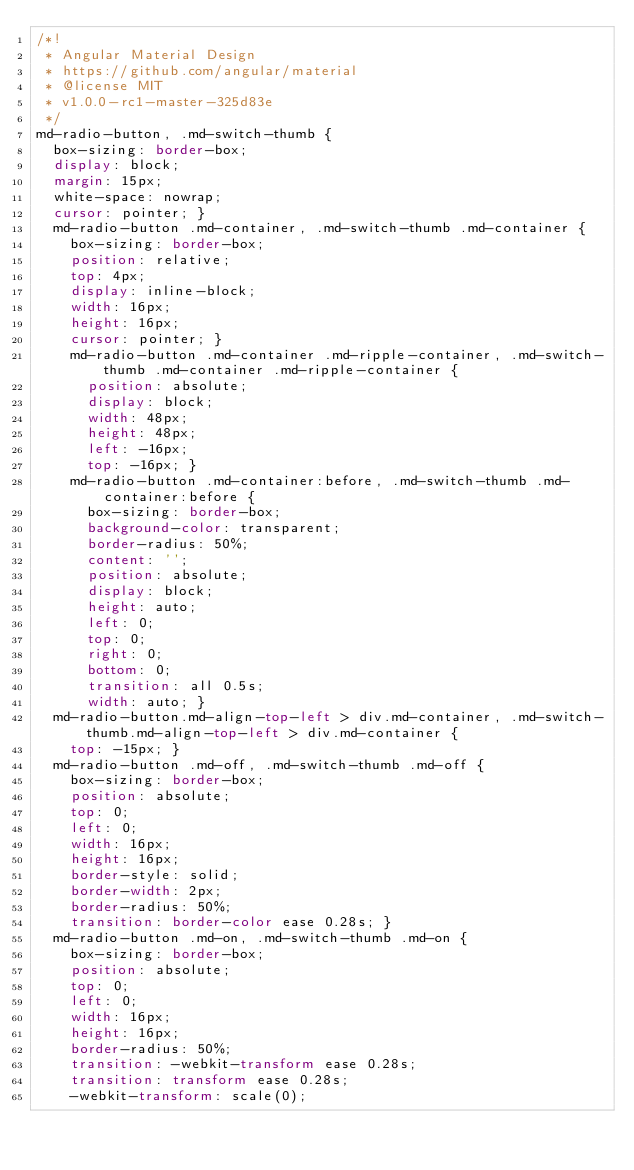Convert code to text. <code><loc_0><loc_0><loc_500><loc_500><_CSS_>/*!
 * Angular Material Design
 * https://github.com/angular/material
 * @license MIT
 * v1.0.0-rc1-master-325d83e
 */
md-radio-button, .md-switch-thumb {
  box-sizing: border-box;
  display: block;
  margin: 15px;
  white-space: nowrap;
  cursor: pointer; }
  md-radio-button .md-container, .md-switch-thumb .md-container {
    box-sizing: border-box;
    position: relative;
    top: 4px;
    display: inline-block;
    width: 16px;
    height: 16px;
    cursor: pointer; }
    md-radio-button .md-container .md-ripple-container, .md-switch-thumb .md-container .md-ripple-container {
      position: absolute;
      display: block;
      width: 48px;
      height: 48px;
      left: -16px;
      top: -16px; }
    md-radio-button .md-container:before, .md-switch-thumb .md-container:before {
      box-sizing: border-box;
      background-color: transparent;
      border-radius: 50%;
      content: '';
      position: absolute;
      display: block;
      height: auto;
      left: 0;
      top: 0;
      right: 0;
      bottom: 0;
      transition: all 0.5s;
      width: auto; }
  md-radio-button.md-align-top-left > div.md-container, .md-switch-thumb.md-align-top-left > div.md-container {
    top: -15px; }
  md-radio-button .md-off, .md-switch-thumb .md-off {
    box-sizing: border-box;
    position: absolute;
    top: 0;
    left: 0;
    width: 16px;
    height: 16px;
    border-style: solid;
    border-width: 2px;
    border-radius: 50%;
    transition: border-color ease 0.28s; }
  md-radio-button .md-on, .md-switch-thumb .md-on {
    box-sizing: border-box;
    position: absolute;
    top: 0;
    left: 0;
    width: 16px;
    height: 16px;
    border-radius: 50%;
    transition: -webkit-transform ease 0.28s;
    transition: transform ease 0.28s;
    -webkit-transform: scale(0);</code> 